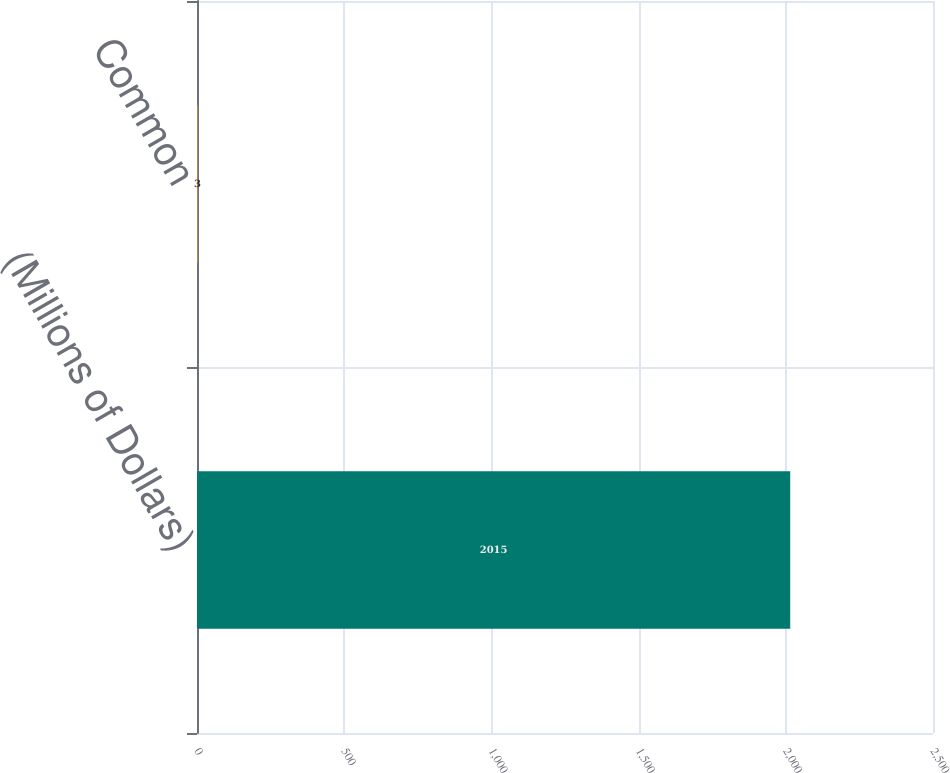Convert chart. <chart><loc_0><loc_0><loc_500><loc_500><bar_chart><fcel>(Millions of Dollars)<fcel>Common<nl><fcel>2015<fcel>3<nl></chart> 